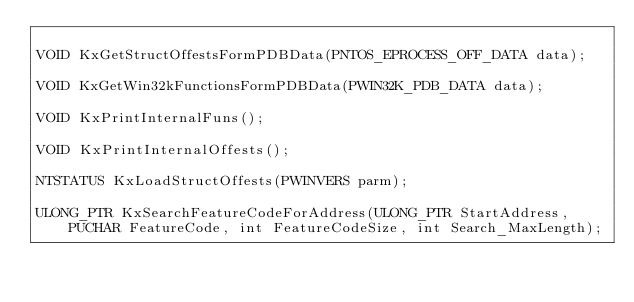Convert code to text. <code><loc_0><loc_0><loc_500><loc_500><_C_>
VOID KxGetStructOffestsFormPDBData(PNTOS_EPROCESS_OFF_DATA data);

VOID KxGetWin32kFunctionsFormPDBData(PWIN32K_PDB_DATA data);

VOID KxPrintInternalFuns();

VOID KxPrintInternalOffests();

NTSTATUS KxLoadStructOffests(PWINVERS parm);

ULONG_PTR KxSearchFeatureCodeForAddress(ULONG_PTR StartAddress, PUCHAR FeatureCode, int FeatureCodeSize, int Search_MaxLength);

</code> 